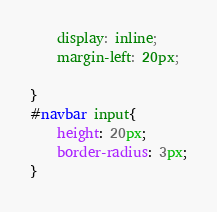Convert code to text. <code><loc_0><loc_0><loc_500><loc_500><_CSS_>	display: inline;
	margin-left: 20px;

}
#navbar input{
	height: 20px;
	border-radius: 3px;
}</code> 